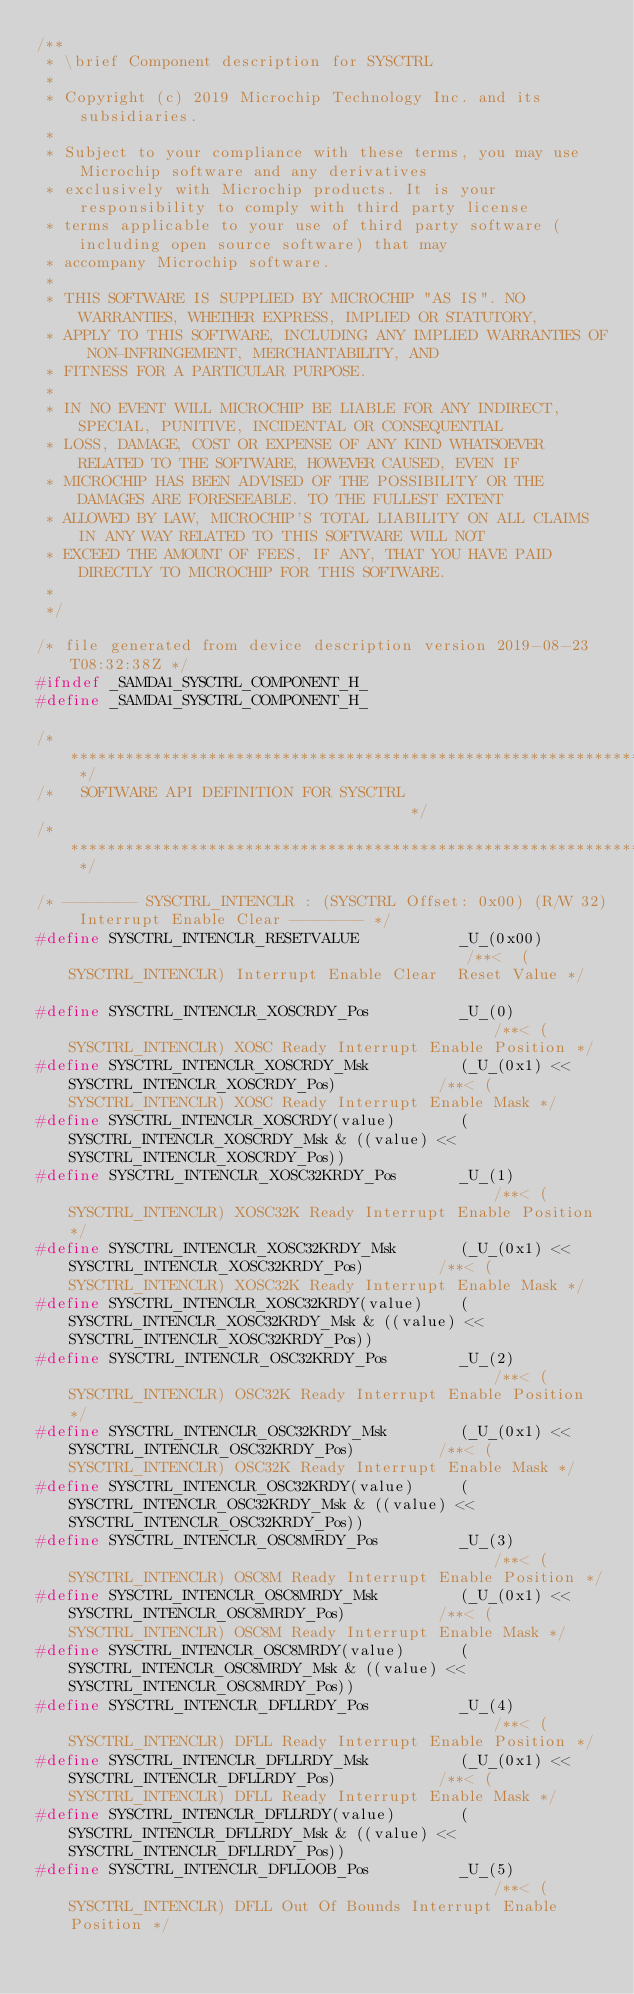Convert code to text. <code><loc_0><loc_0><loc_500><loc_500><_C_>/**
 * \brief Component description for SYSCTRL
 *
 * Copyright (c) 2019 Microchip Technology Inc. and its subsidiaries.
 *
 * Subject to your compliance with these terms, you may use Microchip software and any derivatives
 * exclusively with Microchip products. It is your responsibility to comply with third party license
 * terms applicable to your use of third party software (including open source software) that may
 * accompany Microchip software.
 *
 * THIS SOFTWARE IS SUPPLIED BY MICROCHIP "AS IS". NO WARRANTIES, WHETHER EXPRESS, IMPLIED OR STATUTORY,
 * APPLY TO THIS SOFTWARE, INCLUDING ANY IMPLIED WARRANTIES OF NON-INFRINGEMENT, MERCHANTABILITY, AND
 * FITNESS FOR A PARTICULAR PURPOSE.
 *
 * IN NO EVENT WILL MICROCHIP BE LIABLE FOR ANY INDIRECT, SPECIAL, PUNITIVE, INCIDENTAL OR CONSEQUENTIAL
 * LOSS, DAMAGE, COST OR EXPENSE OF ANY KIND WHATSOEVER RELATED TO THE SOFTWARE, HOWEVER CAUSED, EVEN IF
 * MICROCHIP HAS BEEN ADVISED OF THE POSSIBILITY OR THE DAMAGES ARE FORESEEABLE. TO THE FULLEST EXTENT
 * ALLOWED BY LAW, MICROCHIP'S TOTAL LIABILITY ON ALL CLAIMS IN ANY WAY RELATED TO THIS SOFTWARE WILL NOT
 * EXCEED THE AMOUNT OF FEES, IF ANY, THAT YOU HAVE PAID DIRECTLY TO MICROCHIP FOR THIS SOFTWARE.
 *
 */

/* file generated from device description version 2019-08-23T08:32:38Z */
#ifndef _SAMDA1_SYSCTRL_COMPONENT_H_
#define _SAMDA1_SYSCTRL_COMPONENT_H_

/* ************************************************************************** */
/*   SOFTWARE API DEFINITION FOR SYSCTRL                                      */
/* ************************************************************************** */

/* -------- SYSCTRL_INTENCLR : (SYSCTRL Offset: 0x00) (R/W 32) Interrupt Enable Clear -------- */
#define SYSCTRL_INTENCLR_RESETVALUE           _U_(0x00)                                            /**<  (SYSCTRL_INTENCLR) Interrupt Enable Clear  Reset Value */

#define SYSCTRL_INTENCLR_XOSCRDY_Pos          _U_(0)                                               /**< (SYSCTRL_INTENCLR) XOSC Ready Interrupt Enable Position */
#define SYSCTRL_INTENCLR_XOSCRDY_Msk          (_U_(0x1) << SYSCTRL_INTENCLR_XOSCRDY_Pos)           /**< (SYSCTRL_INTENCLR) XOSC Ready Interrupt Enable Mask */
#define SYSCTRL_INTENCLR_XOSCRDY(value)       (SYSCTRL_INTENCLR_XOSCRDY_Msk & ((value) << SYSCTRL_INTENCLR_XOSCRDY_Pos))
#define SYSCTRL_INTENCLR_XOSC32KRDY_Pos       _U_(1)                                               /**< (SYSCTRL_INTENCLR) XOSC32K Ready Interrupt Enable Position */
#define SYSCTRL_INTENCLR_XOSC32KRDY_Msk       (_U_(0x1) << SYSCTRL_INTENCLR_XOSC32KRDY_Pos)        /**< (SYSCTRL_INTENCLR) XOSC32K Ready Interrupt Enable Mask */
#define SYSCTRL_INTENCLR_XOSC32KRDY(value)    (SYSCTRL_INTENCLR_XOSC32KRDY_Msk & ((value) << SYSCTRL_INTENCLR_XOSC32KRDY_Pos))
#define SYSCTRL_INTENCLR_OSC32KRDY_Pos        _U_(2)                                               /**< (SYSCTRL_INTENCLR) OSC32K Ready Interrupt Enable Position */
#define SYSCTRL_INTENCLR_OSC32KRDY_Msk        (_U_(0x1) << SYSCTRL_INTENCLR_OSC32KRDY_Pos)         /**< (SYSCTRL_INTENCLR) OSC32K Ready Interrupt Enable Mask */
#define SYSCTRL_INTENCLR_OSC32KRDY(value)     (SYSCTRL_INTENCLR_OSC32KRDY_Msk & ((value) << SYSCTRL_INTENCLR_OSC32KRDY_Pos))
#define SYSCTRL_INTENCLR_OSC8MRDY_Pos         _U_(3)                                               /**< (SYSCTRL_INTENCLR) OSC8M Ready Interrupt Enable Position */
#define SYSCTRL_INTENCLR_OSC8MRDY_Msk         (_U_(0x1) << SYSCTRL_INTENCLR_OSC8MRDY_Pos)          /**< (SYSCTRL_INTENCLR) OSC8M Ready Interrupt Enable Mask */
#define SYSCTRL_INTENCLR_OSC8MRDY(value)      (SYSCTRL_INTENCLR_OSC8MRDY_Msk & ((value) << SYSCTRL_INTENCLR_OSC8MRDY_Pos))
#define SYSCTRL_INTENCLR_DFLLRDY_Pos          _U_(4)                                               /**< (SYSCTRL_INTENCLR) DFLL Ready Interrupt Enable Position */
#define SYSCTRL_INTENCLR_DFLLRDY_Msk          (_U_(0x1) << SYSCTRL_INTENCLR_DFLLRDY_Pos)           /**< (SYSCTRL_INTENCLR) DFLL Ready Interrupt Enable Mask */
#define SYSCTRL_INTENCLR_DFLLRDY(value)       (SYSCTRL_INTENCLR_DFLLRDY_Msk & ((value) << SYSCTRL_INTENCLR_DFLLRDY_Pos))
#define SYSCTRL_INTENCLR_DFLLOOB_Pos          _U_(5)                                               /**< (SYSCTRL_INTENCLR) DFLL Out Of Bounds Interrupt Enable Position */</code> 